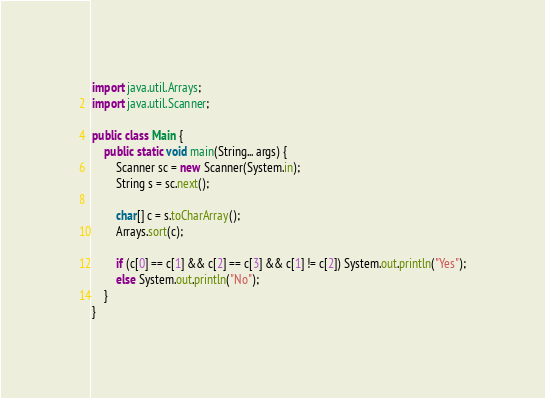<code> <loc_0><loc_0><loc_500><loc_500><_Java_>import java.util.Arrays;
import java.util.Scanner;

public class Main {
    public static void main(String... args) {
        Scanner sc = new Scanner(System.in);
        String s = sc.next();

        char[] c = s.toCharArray();
        Arrays.sort(c);

        if (c[0] == c[1] && c[2] == c[3] && c[1] != c[2]) System.out.println("Yes");
        else System.out.println("No");
    }
}</code> 